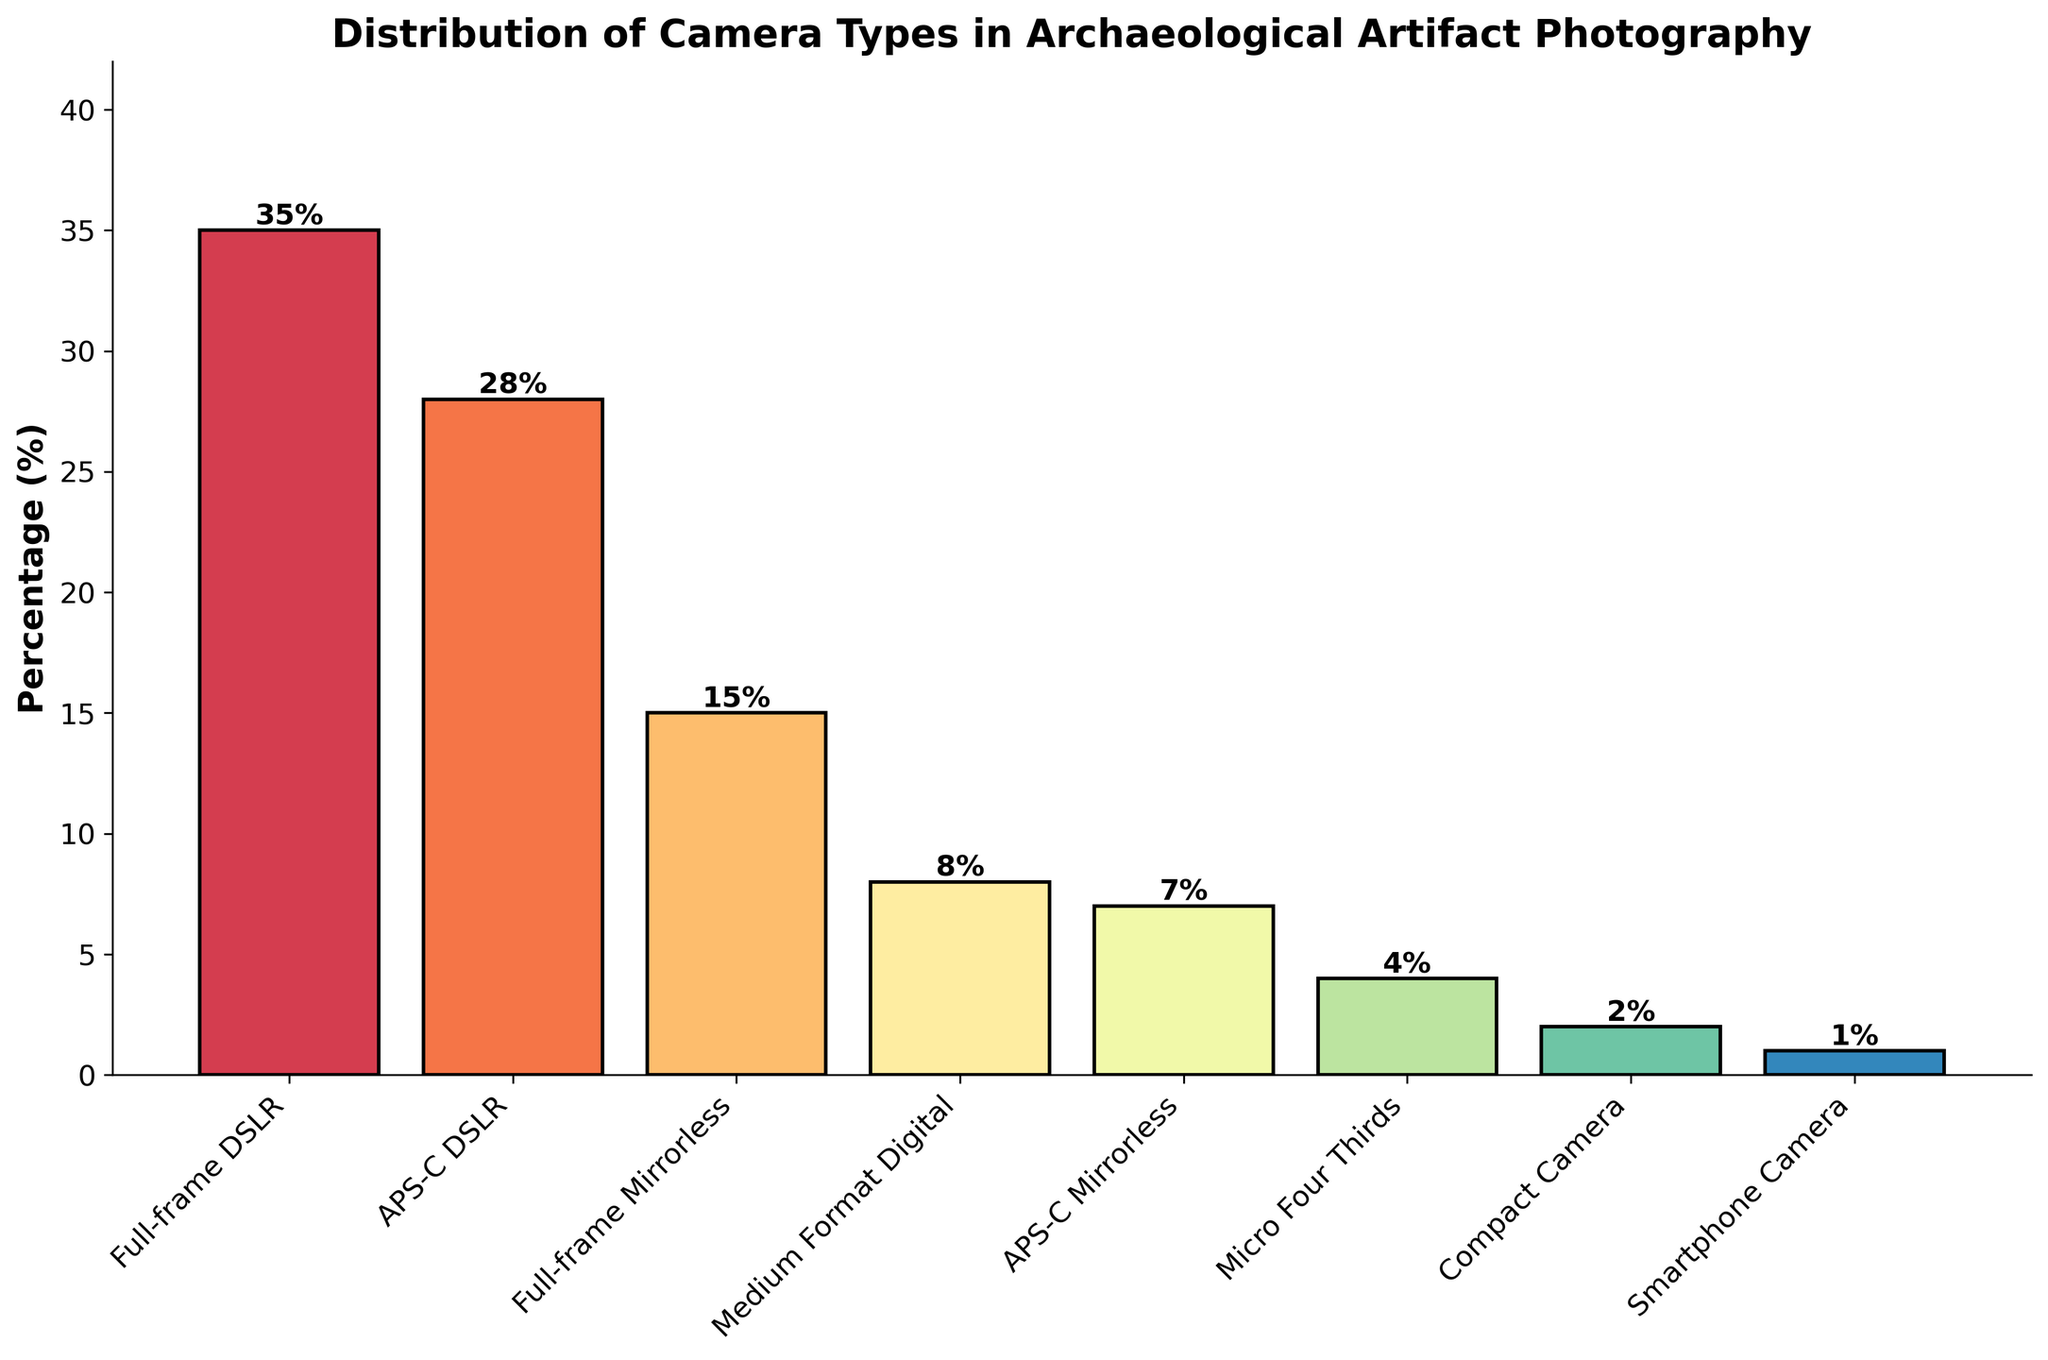Which camera type has the highest percentage usage in archaeological artifact photography? The bar representing "Full-frame DSLR" reaches the highest point on the y-axis compared to other bars, indicating a 35% usage.
Answer: Full-frame DSLR How much higher is the percentage of Full-frame DSLR compared to APS-C Mirrorless? The percentage usage of Full-frame DSLR is 35%. The percentage usage of APS-C Mirrorless is 7%. Subtract 7 from 35: 35 - 7 = 28.
Answer: 28% Which camera types have a usage percentage below 10%? The bars representing Medium Format Digital (8%), APS-C Mirrorless (7%), Micro Four Thirds (4%), Compact Camera (2%), and Smartphone Camera (1%) all do not reach the 10% mark on the y-axis.
Answer: Medium Format Digital, APS-C Mirrorless, Micro Four Thirds, Compact Camera, Smartphone Camera What is the total percentage usage of all mirrorless camera types? Add the percentages of Full-frame Mirrorless (15%), APS-C Mirrorless (7%), and Micro Four Thirds (4%): 15 + 7 + 4 = 26.
Answer: 26% Which camera type has the smallest percentage usage? The bar representing "Smartphone Camera" is the shortest, reaching only 1% on the y-axis.
Answer: Smartphone Camera Is the percentage of Full-frame DSLR usage greater than the combined percentage of Compact Camera and Smartphone Camera? The percentage usage of Full-frame DSLR is 35%. The combined percentage of Compact Camera (2%) and Smartphone Camera (1%) is 2 + 1 = 3%. Since 35 > 3, the answer is yes.
Answer: Yes Which category has more usage, APS-C DSLRs or APS-C Mirrorless cameras? The bar for APS-C DSLRs reaches 28% on the y-axis, while the bar for APS-C Mirrorless cameras reaches 7%. Since 28 is greater than 7, APS-C DSLRs have more usage.
Answer: APS-C DSLRs What percentage difference is there between the usage of Full-frame Mirrorless and Micro Four Thirds cameras? Full-frame Mirrorless has 15% usage, and Micro Four Thirds has 4% usage. Subtract 4 from 15: 15 - 4 = 11.
Answer: 11% Does any single camera type have a percentage that exceeds the combined percentage of APS-C DSLRs and APS-C Mirrorless cameras? The combined percentage of APS-C DSLRs (28%) and APS-C Mirrorless cameras (7%) is 28 + 7 = 35%. The highest single value is Full-frame DSLR at 35%, which is equal but not exceeding 35%.
Answer: No 